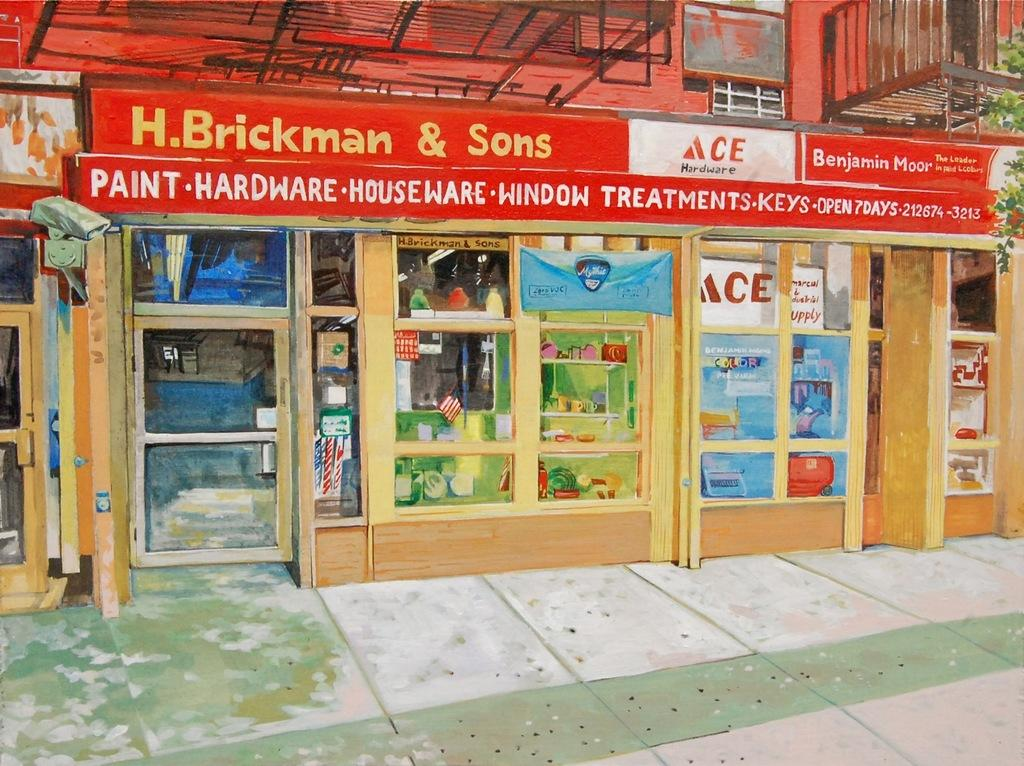<image>
Share a concise interpretation of the image provided. the store front gor h.brckman and sons hardware 